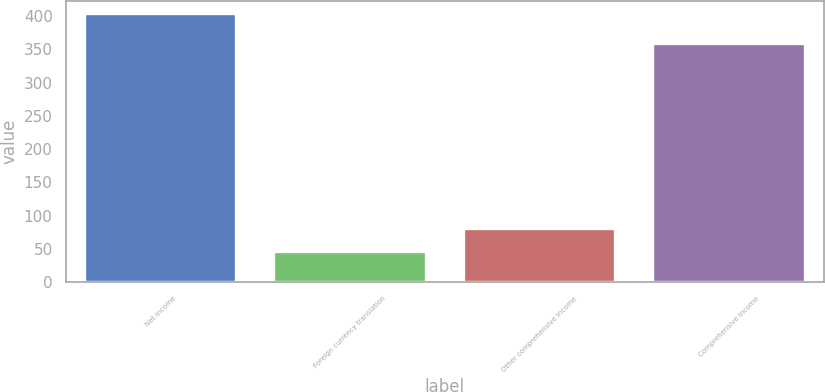Convert chart. <chart><loc_0><loc_0><loc_500><loc_500><bar_chart><fcel>Net income<fcel>Foreign currency translation<fcel>Other comprehensive income<fcel>Comprehensive income<nl><fcel>403.1<fcel>44.5<fcel>80.36<fcel>358.6<nl></chart> 